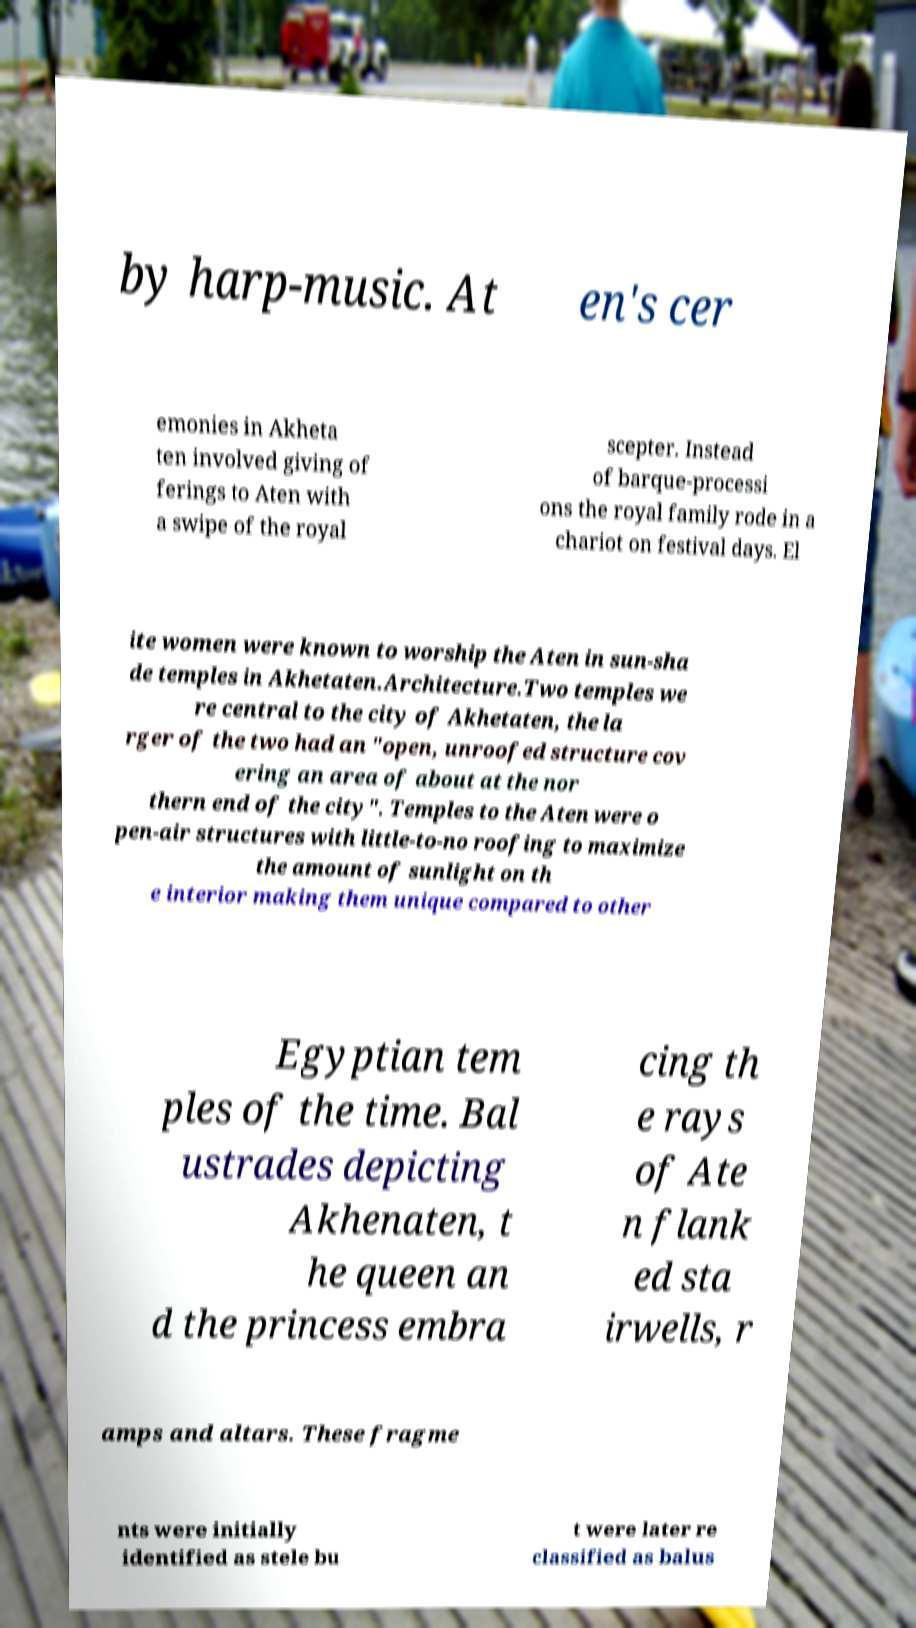Please read and relay the text visible in this image. What does it say? by harp-music. At en's cer emonies in Akheta ten involved giving of ferings to Aten with a swipe of the royal scepter. Instead of barque-processi ons the royal family rode in a chariot on festival days. El ite women were known to worship the Aten in sun-sha de temples in Akhetaten.Architecture.Two temples we re central to the city of Akhetaten, the la rger of the two had an "open, unroofed structure cov ering an area of about at the nor thern end of the city". Temples to the Aten were o pen-air structures with little-to-no roofing to maximize the amount of sunlight on th e interior making them unique compared to other Egyptian tem ples of the time. Bal ustrades depicting Akhenaten, t he queen an d the princess embra cing th e rays of Ate n flank ed sta irwells, r amps and altars. These fragme nts were initially identified as stele bu t were later re classified as balus 